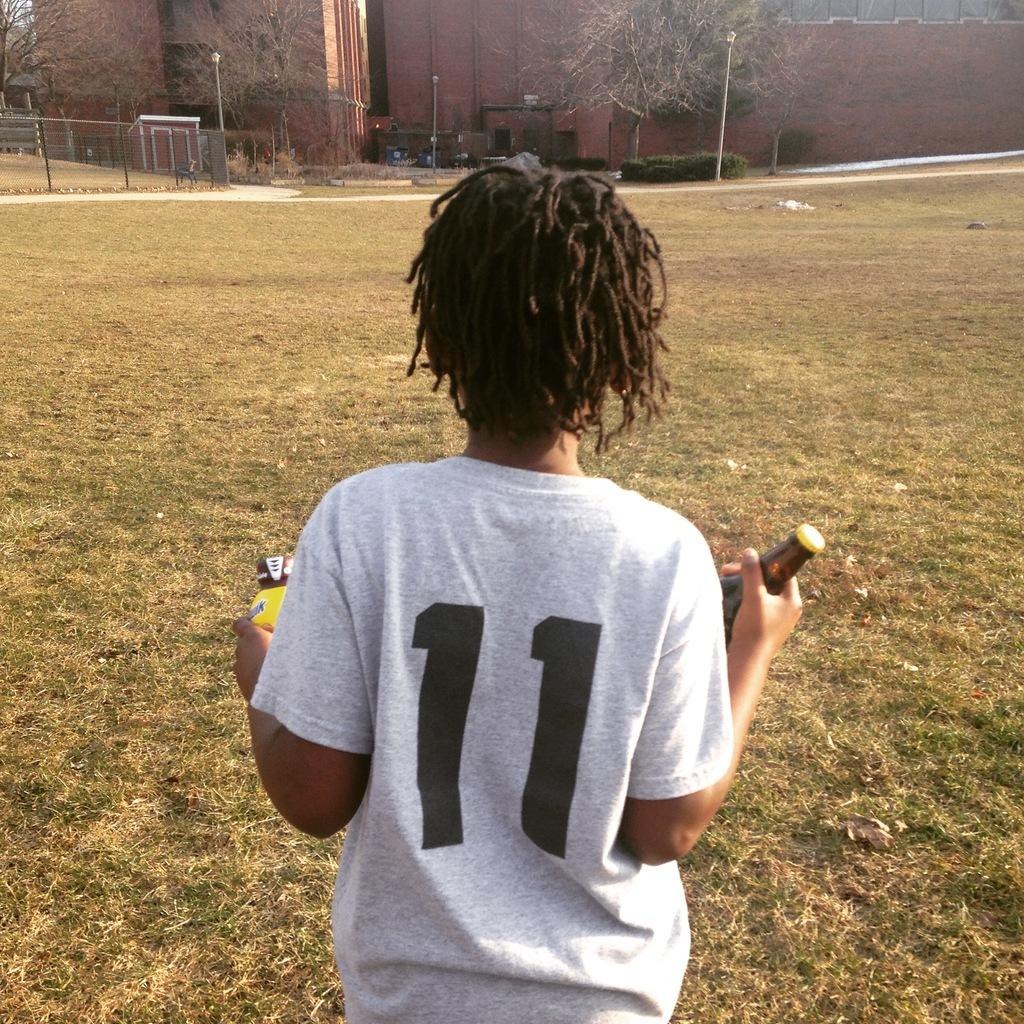<image>
Render a clear and concise summary of the photo. A person has there back facing the camera and is wearing a light colored shirt with the number 11 on it. 